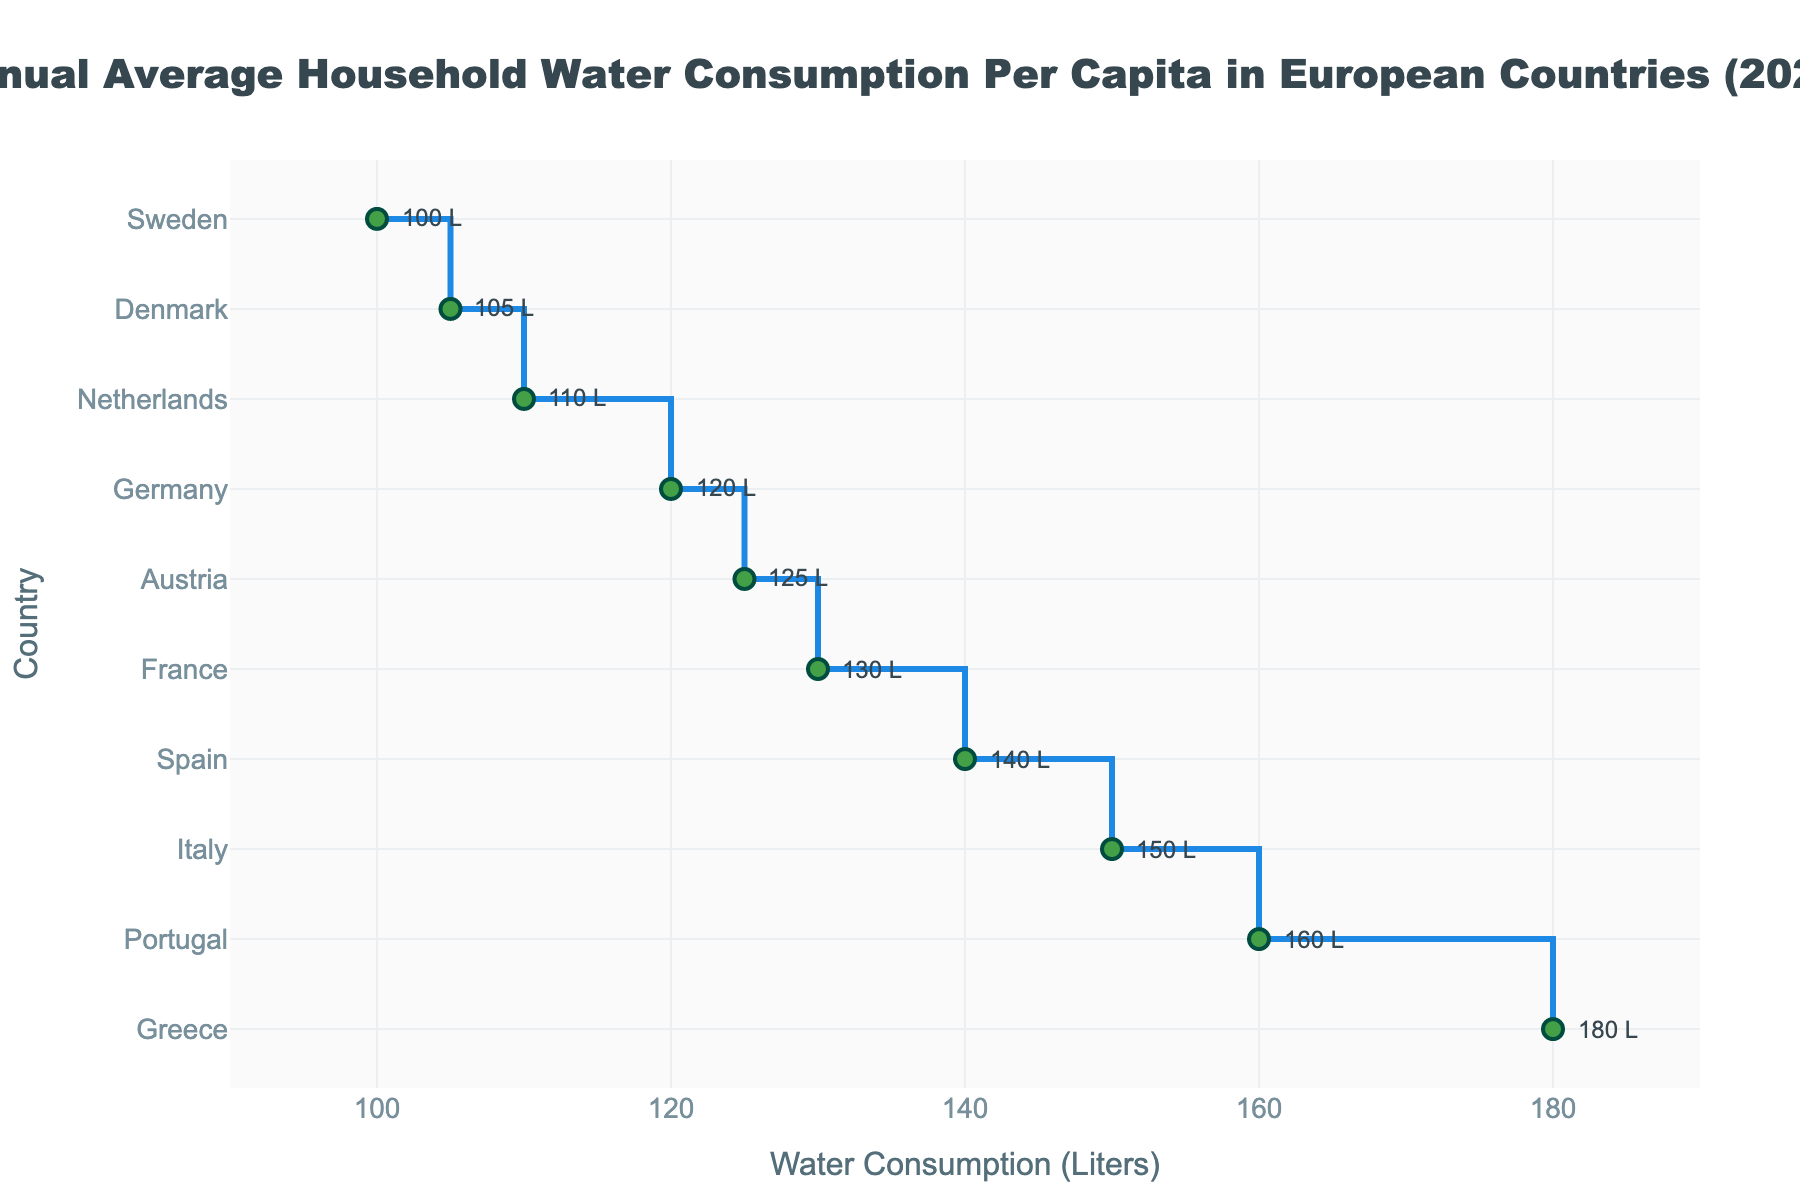What is the title of the plot? The title of the plot is displayed at the top center of the plot. It provides an overview of what the plot represents.
Answer: Annual Average Household Water Consumption Per Capita in European Countries (2021) Which country has the highest annual average household water consumption per capita? The stair plot orders the countries by water consumption in descending order. The first marker and label indicate the highest value.
Answer: Greece What is the annual average household water consumption per capita in Austria? The y-axis contains the list of countries, and across from Austria is the water consumption value shown in liters.
Answer: 125 liters Which countries have a lower annual average household water consumption per capita than Italy? Countries with lower water consumption than Italy would be located below Italy on the y-axis in the stair plot. These countries include Spain, France, Germany, Austria, Denmark, Netherlands, and Sweden.
Answer: Spain, France, Germany, Austria, Denmark, Netherlands, Sweden How much higher is Greece’s water consumption compared to Sweden’s? Locate Greece and Sweden on the y-axis and note their consumption values. Then subtract Sweden's consumption from Greece's consumption. 180 - 100 = 80 liters.
Answer: 80 liters What is the median annual average household water consumption per capita among the listed countries? To find the median, sort the data points in ascending order and identify the middle value(s). The sorted list is: Sweden (100), Denmark (105), Netherlands (110), Germany (120), Austria (125), France (130), Spain (140), Italy (150), Portugal (160), Greece (180). The middle values are Germany (120) and Austria (125), therefore the median is (120+125)/2 = 122.5 liters.
Answer: 122.5 liters Which country is closest to the average annual household water consumption per capita among the listed countries? Calculate the average by summing all values and dividing by the number of countries. Then find the country whose consumption is closest to this value. The sum is 1320 liters, and the average is 1320 / 10 = 132 liters. France’s value (130 liters) is the closest to this average.
Answer: France What is the range of annual average household water consumption per capita in the listed countries? The range is found by subtracting the smallest value from the largest value. The highest value is Greece's 180 liters, and the lowest is Sweden's 100 liters. The range is 180 - 100 = 80 liters.
Answer: 80 liters How many countries have an annual average household water consumption per capita exceeding 150 liters? Identify all countries with consumption values above 150 liters. From the plot, these countries are Italy, Portugal, and Greece.
Answer: 3 countries Which two countries have the closest water consumption values? Compare the water consumption values of all countries to find the pair with the smallest difference. Austria (125 liters) and Germany (120 liters) have the smallest difference of 5 liters.
Answer: Austria and Germany 